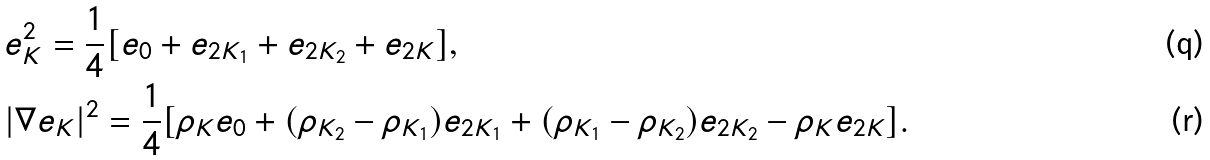Convert formula to latex. <formula><loc_0><loc_0><loc_500><loc_500>& e ^ { 2 } _ { K } = \frac { 1 } { 4 } [ e _ { 0 } + e _ { 2 K _ { 1 } } + e _ { 2 K _ { 2 } } + e _ { 2 K } ] , \\ & | \nabla e _ { K } | ^ { 2 } = \frac { 1 } { 4 } [ \rho _ { K } e _ { 0 } + ( \rho _ { K _ { 2 } } - \rho _ { K _ { 1 } } ) e _ { 2 K _ { 1 } } + ( \rho _ { K _ { 1 } } - \rho _ { K _ { 2 } } ) e _ { 2 K _ { 2 } } - \rho _ { K } e _ { 2 K } ] .</formula> 